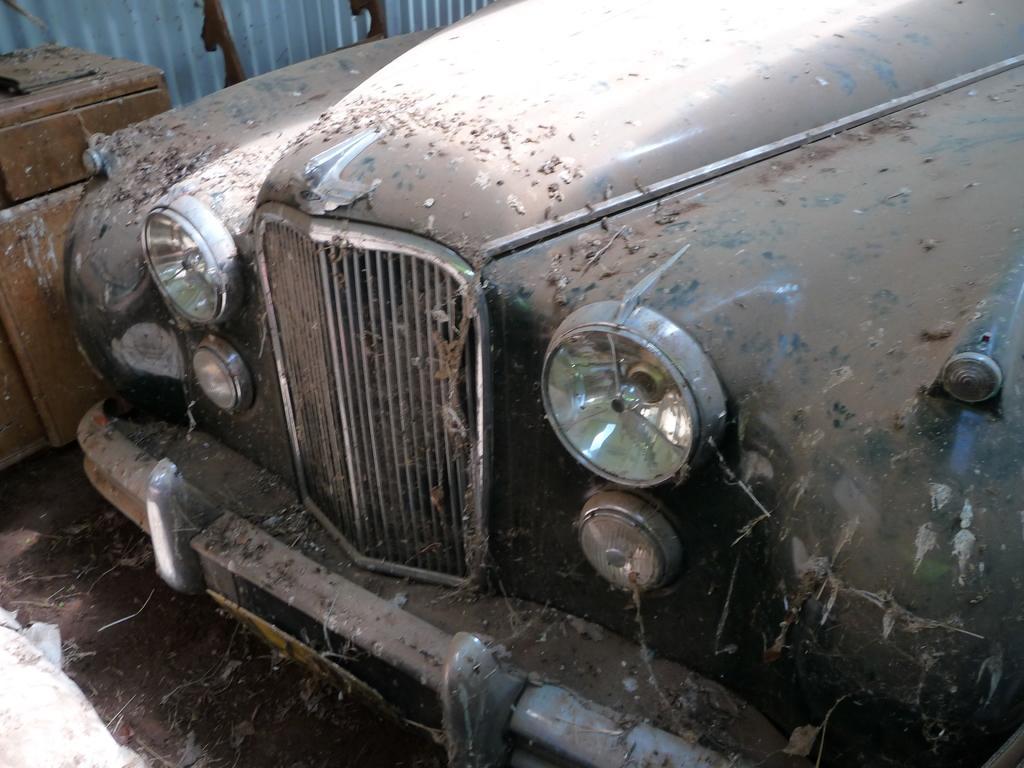Can you describe this image briefly? We can see a vehicle on the ground and there is dust on it. On the left there is a wooden object,metal sheet and another object on the ground. 